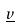<formula> <loc_0><loc_0><loc_500><loc_500>\underline { v }</formula> 